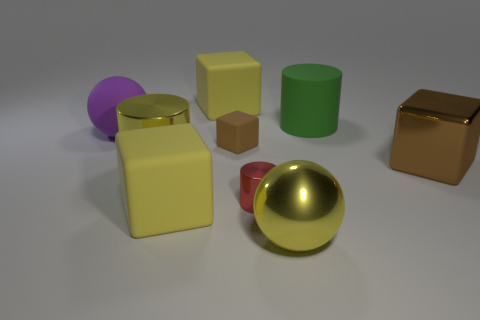There is a brown block that is the same size as the yellow shiny ball; what material is it?
Give a very brief answer. Metal. What is the material of the cylinder that is the same color as the big shiny ball?
Ensure brevity in your answer.  Metal. Are there fewer yellow balls that are in front of the large shiny ball than balls?
Provide a short and direct response. Yes. How many yellow shiny things are there?
Provide a short and direct response. 2. What number of small red cylinders are made of the same material as the purple thing?
Your answer should be compact. 0. What number of things are either yellow rubber cubes behind the purple rubber thing or yellow cylinders?
Your answer should be very brief. 2. Is the number of brown metal blocks that are in front of the large yellow cylinder less than the number of shiny cylinders in front of the large purple rubber object?
Give a very brief answer. Yes. There is a big yellow shiny sphere; are there any tiny matte cubes to the right of it?
Make the answer very short. No. How many things are either big yellow things left of the large yellow sphere or rubber objects that are in front of the large purple ball?
Offer a terse response. 4. How many rubber cubes have the same color as the large metallic cylinder?
Your response must be concise. 2. 